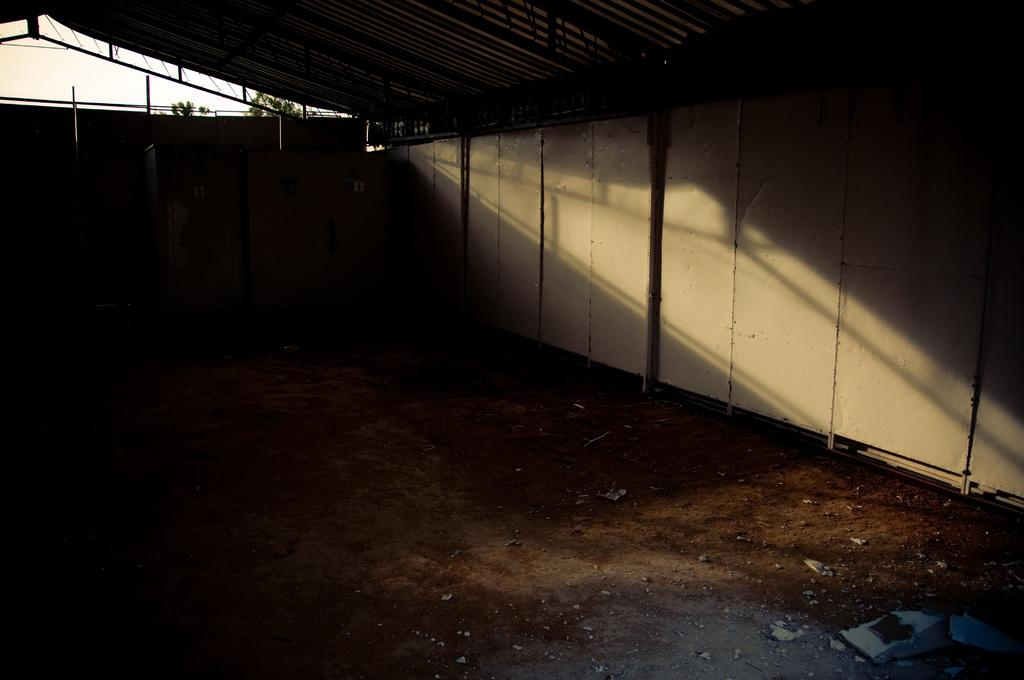What type of structure is present in the image? There is a tin shed in the image. What other natural elements can be seen in the image? There are trees in the image. What part of the environment is visible in the image? The sky is visible in the image. Based on the presence of the sky and trees, can we determine the time of day the image was taken? The image was likely taken during the day, as the sky is visible and there is sufficient light. What caption would best describe the image? There is no caption provided with the image, so it is impossible to determine the best caption. 